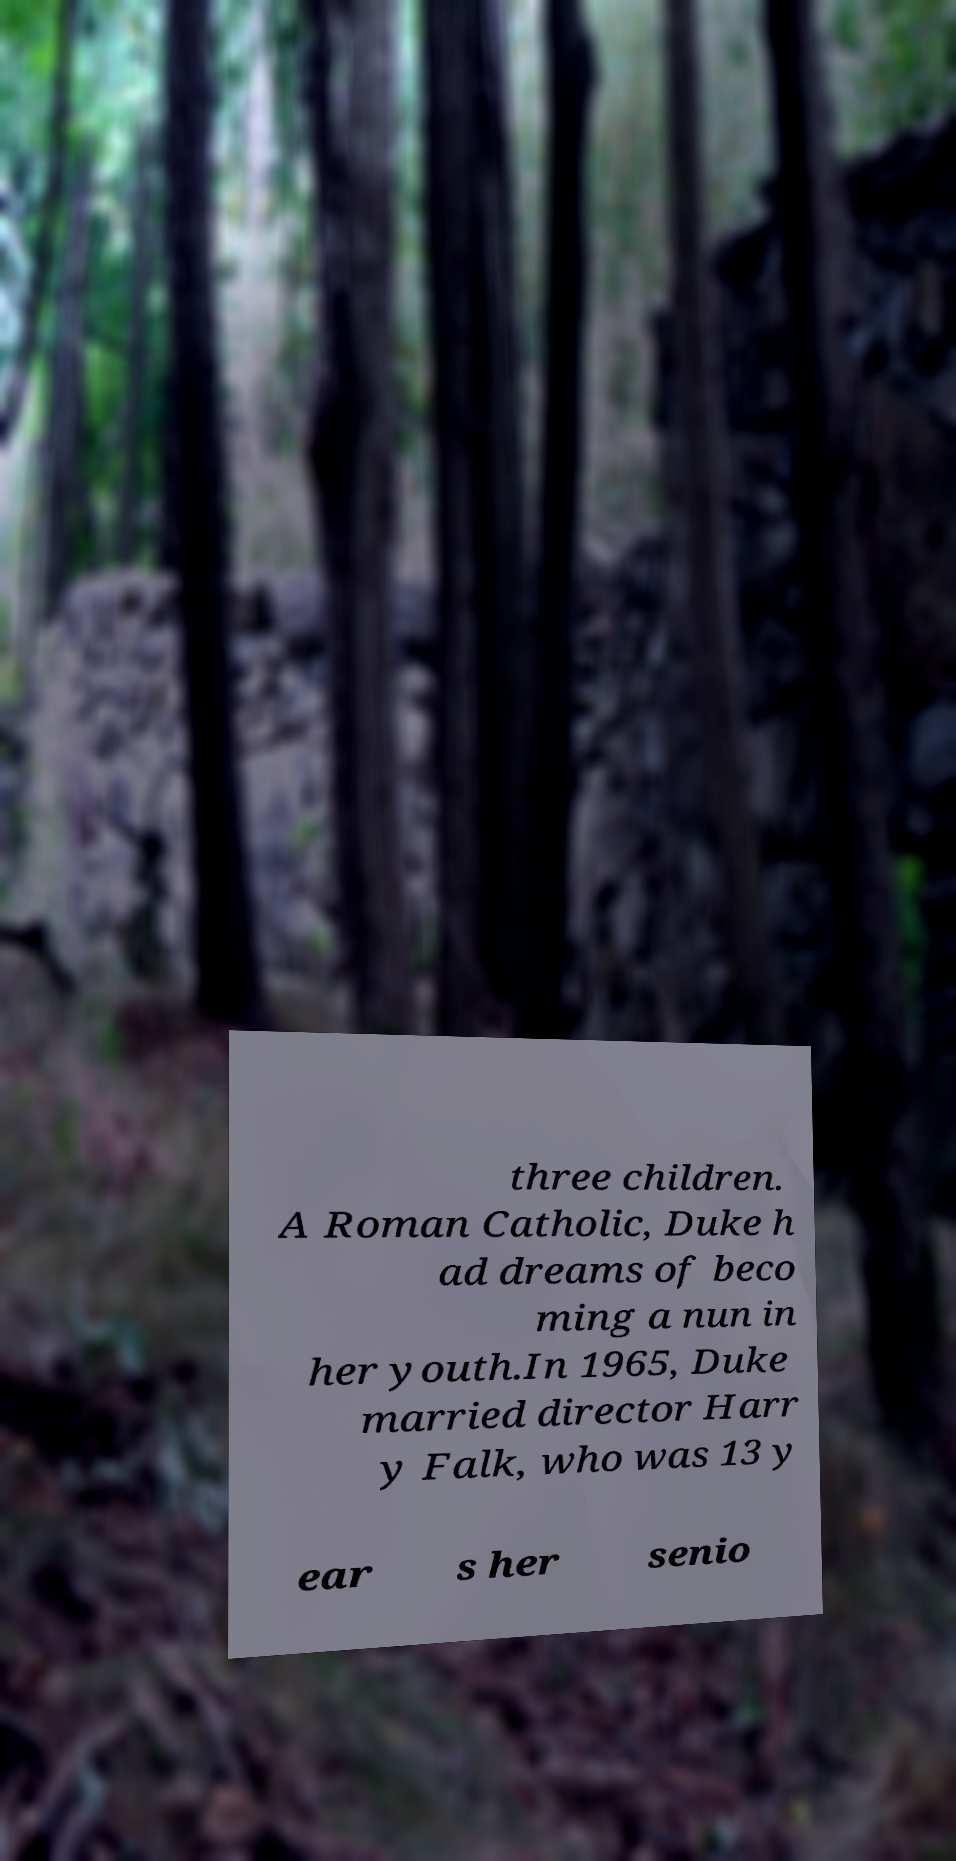Please identify and transcribe the text found in this image. three children. A Roman Catholic, Duke h ad dreams of beco ming a nun in her youth.In 1965, Duke married director Harr y Falk, who was 13 y ear s her senio 